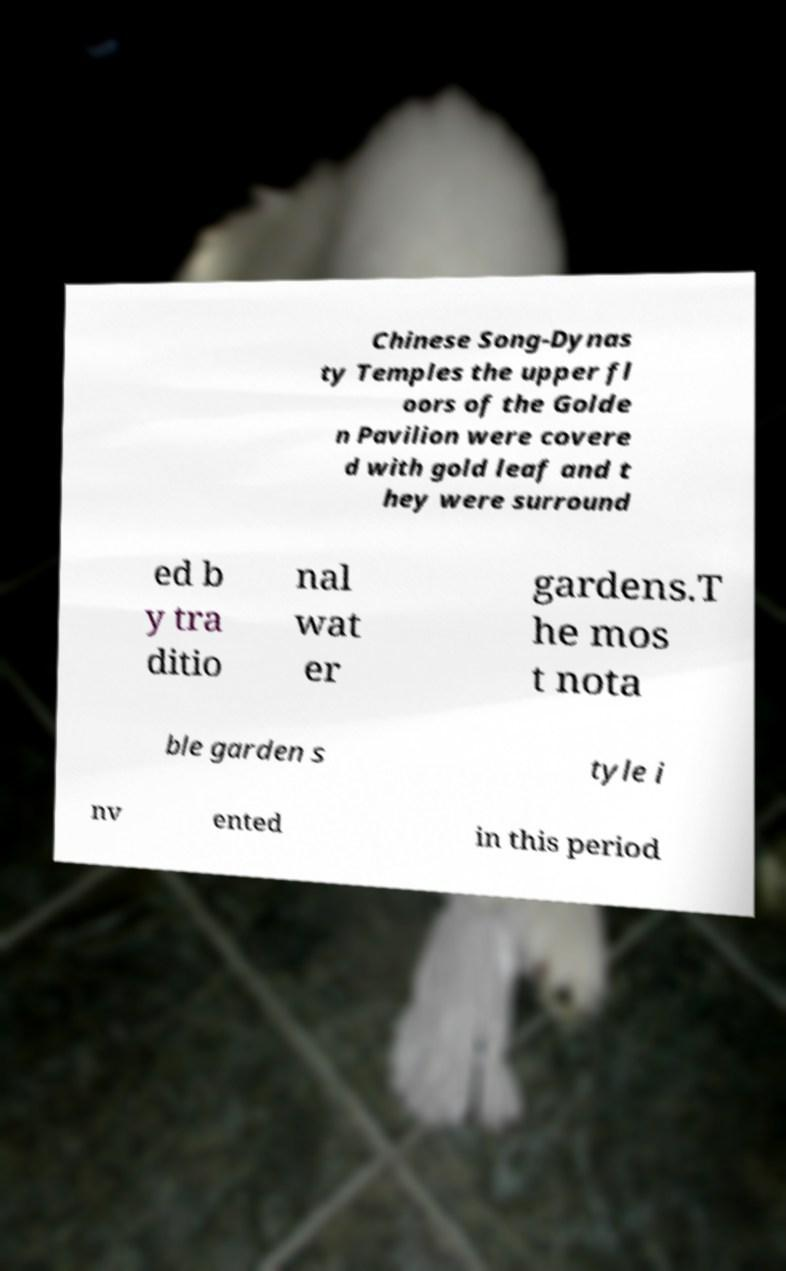Can you read and provide the text displayed in the image?This photo seems to have some interesting text. Can you extract and type it out for me? Chinese Song-Dynas ty Temples the upper fl oors of the Golde n Pavilion were covere d with gold leaf and t hey were surround ed b y tra ditio nal wat er gardens.T he mos t nota ble garden s tyle i nv ented in this period 